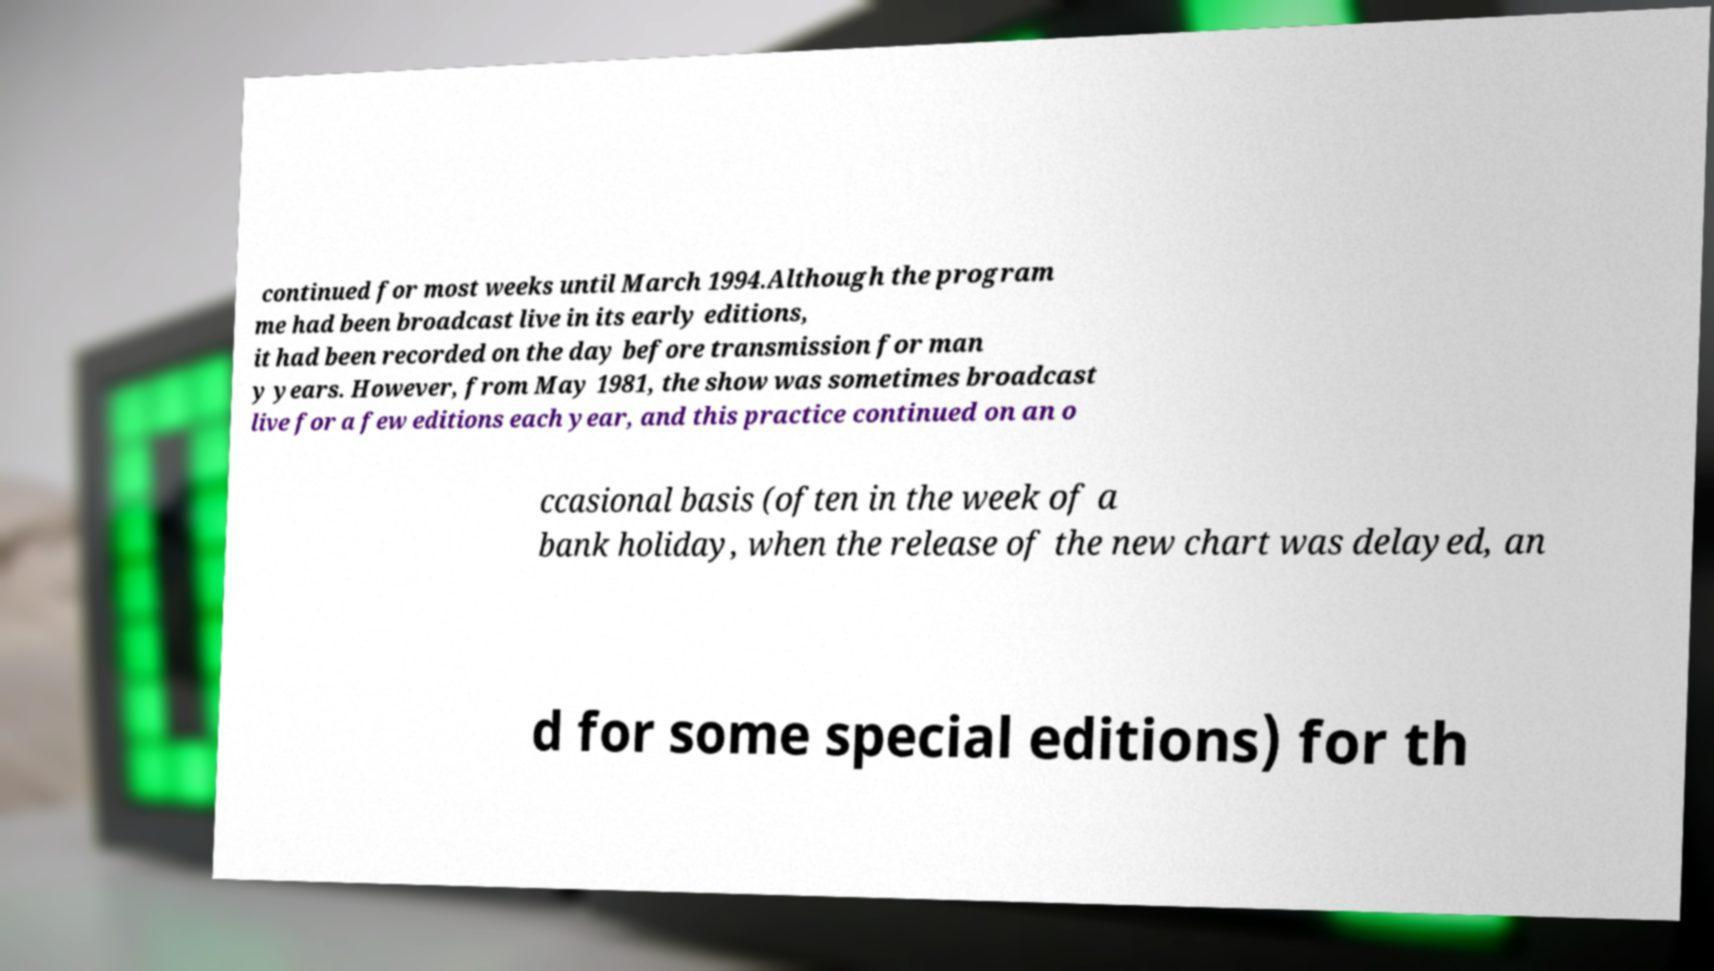Could you assist in decoding the text presented in this image and type it out clearly? continued for most weeks until March 1994.Although the program me had been broadcast live in its early editions, it had been recorded on the day before transmission for man y years. However, from May 1981, the show was sometimes broadcast live for a few editions each year, and this practice continued on an o ccasional basis (often in the week of a bank holiday, when the release of the new chart was delayed, an d for some special editions) for th 